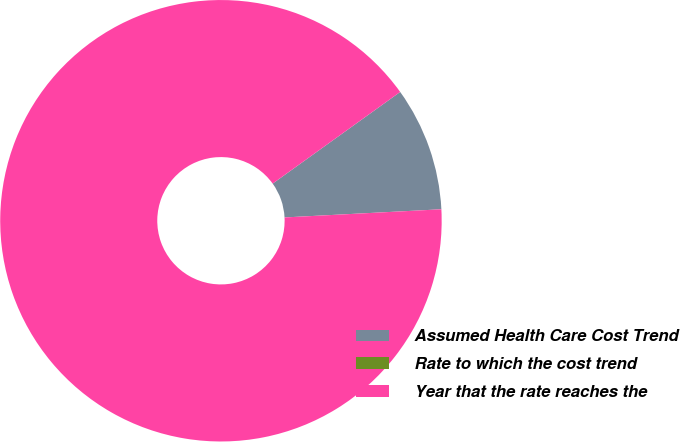Convert chart to OTSL. <chart><loc_0><loc_0><loc_500><loc_500><pie_chart><fcel>Assumed Health Care Cost Trend<fcel>Rate to which the cost trend<fcel>Year that the rate reaches the<nl><fcel>9.09%<fcel>0.0%<fcel>90.91%<nl></chart> 